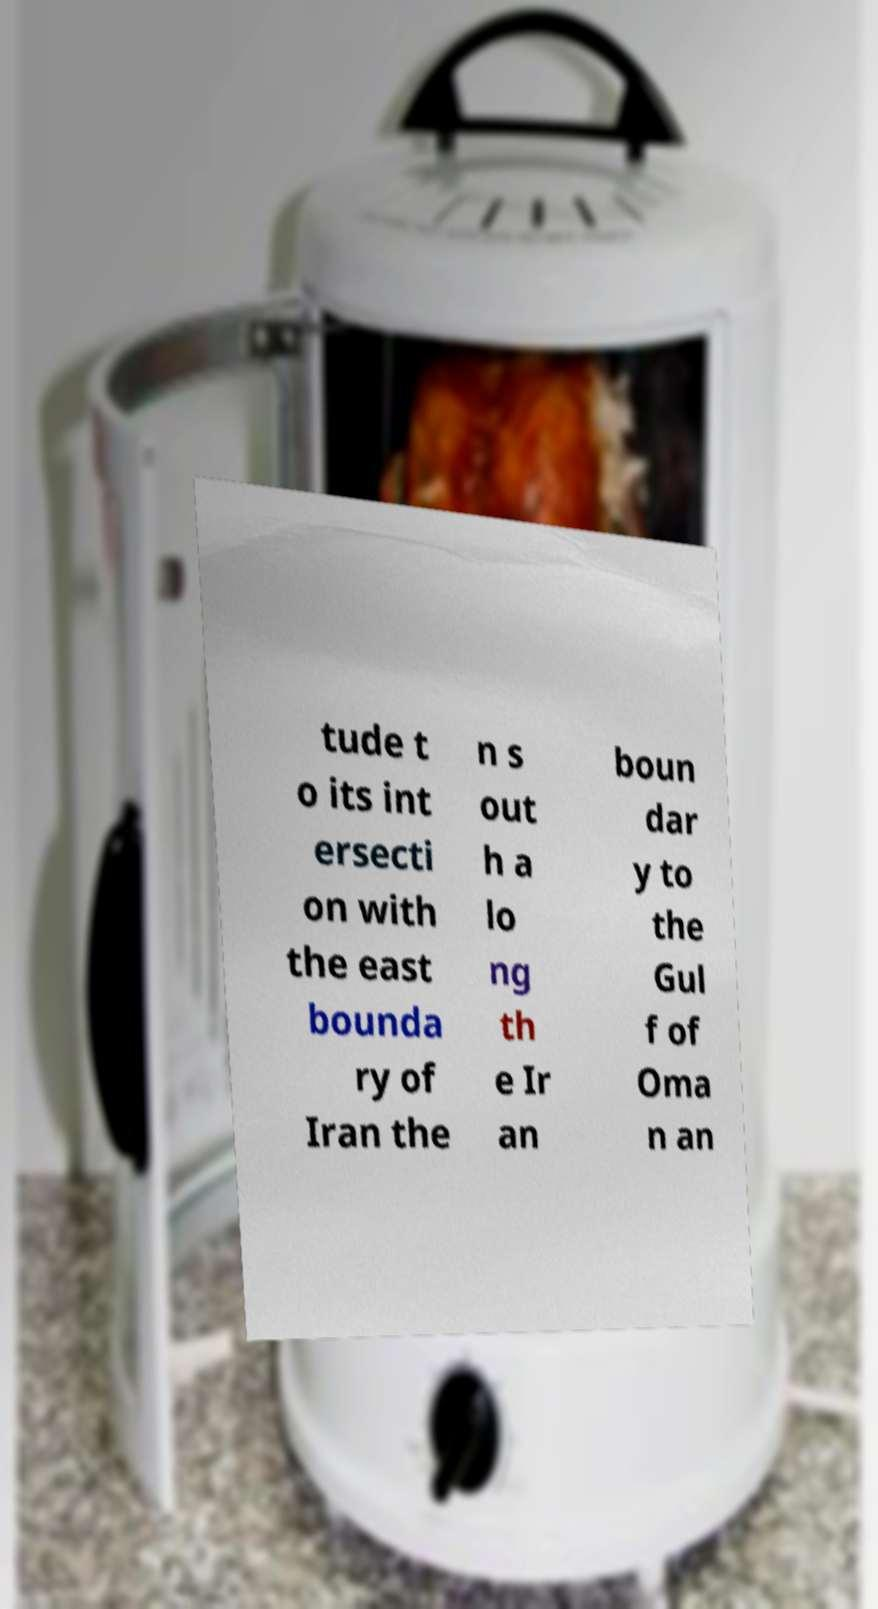Can you accurately transcribe the text from the provided image for me? tude t o its int ersecti on with the east bounda ry of Iran the n s out h a lo ng th e Ir an boun dar y to the Gul f of Oma n an 